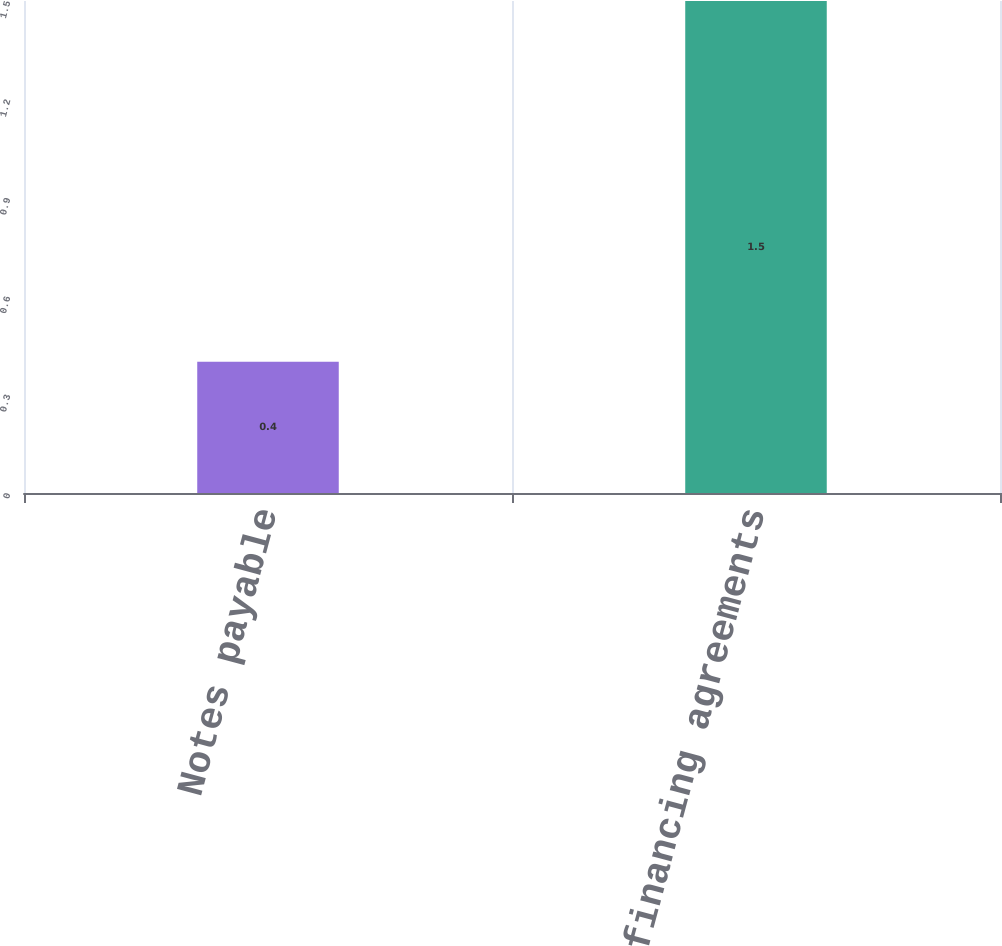Convert chart. <chart><loc_0><loc_0><loc_500><loc_500><bar_chart><fcel>Notes payable<fcel>Fees on financing agreements<nl><fcel>0.4<fcel>1.5<nl></chart> 